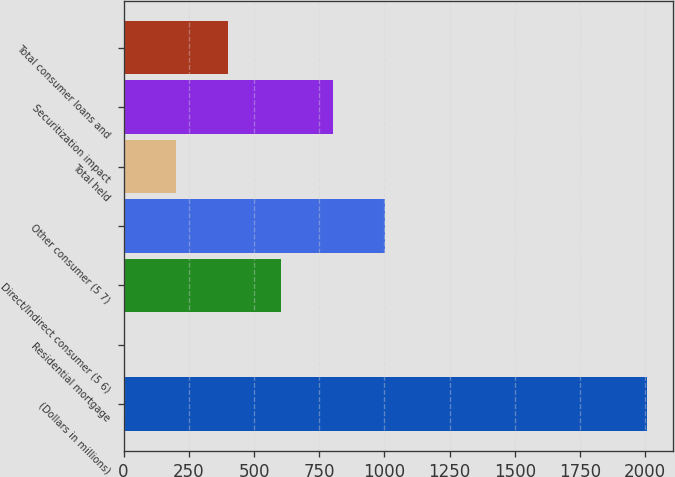Convert chart. <chart><loc_0><loc_0><loc_500><loc_500><bar_chart><fcel>(Dollars in millions)<fcel>Residential mortgage<fcel>Direct/Indirect consumer (5 6)<fcel>Other consumer (5 7)<fcel>Total held<fcel>Securitization impact<fcel>Total consumer loans and<nl><fcel>2007<fcel>0.02<fcel>602.12<fcel>1003.52<fcel>200.72<fcel>802.82<fcel>401.42<nl></chart> 